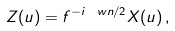Convert formula to latex. <formula><loc_0><loc_0><loc_500><loc_500>Z ( u ) = f ^ { - i \ w n / 2 } X ( u ) \, ,</formula> 